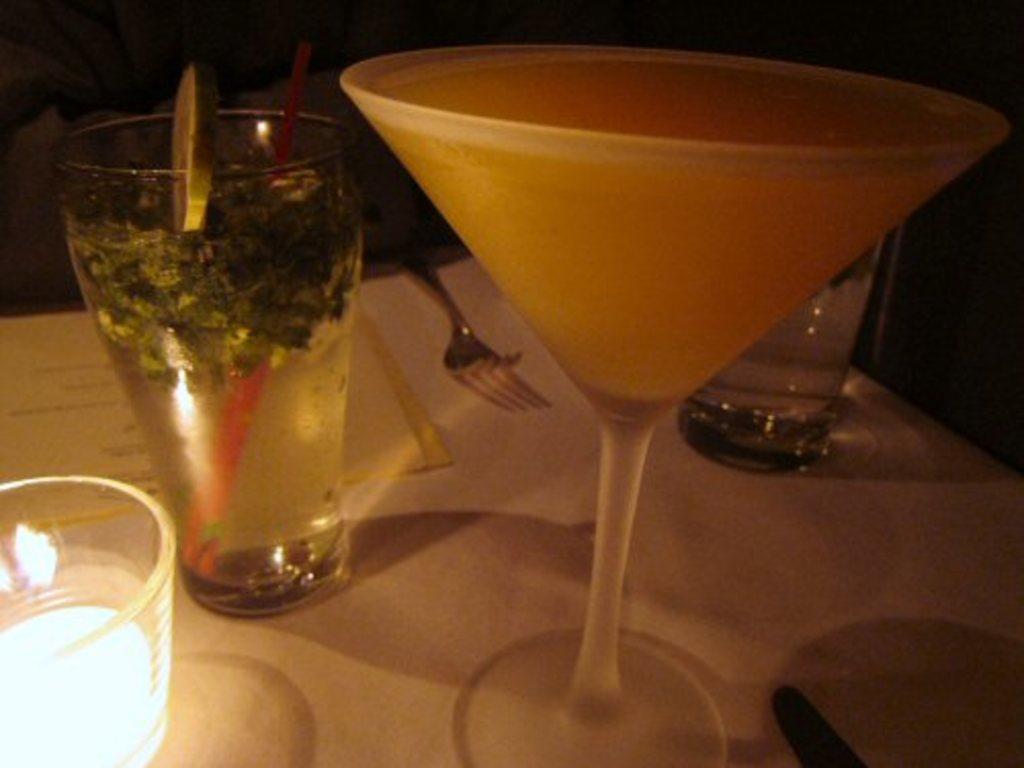Please provide a concise description of this image. In this image I can see the white colored table. On the table I can see few glasses with liquids in them, a fork and a light. I can see the dark background. 